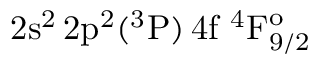Convert formula to latex. <formula><loc_0><loc_0><loc_500><loc_500>2 s ^ { 2 } \, 2 p ^ { 2 } ( ^ { 3 } P ) \, 4 f ^ { 4 } F _ { 9 / 2 } ^ { o }</formula> 